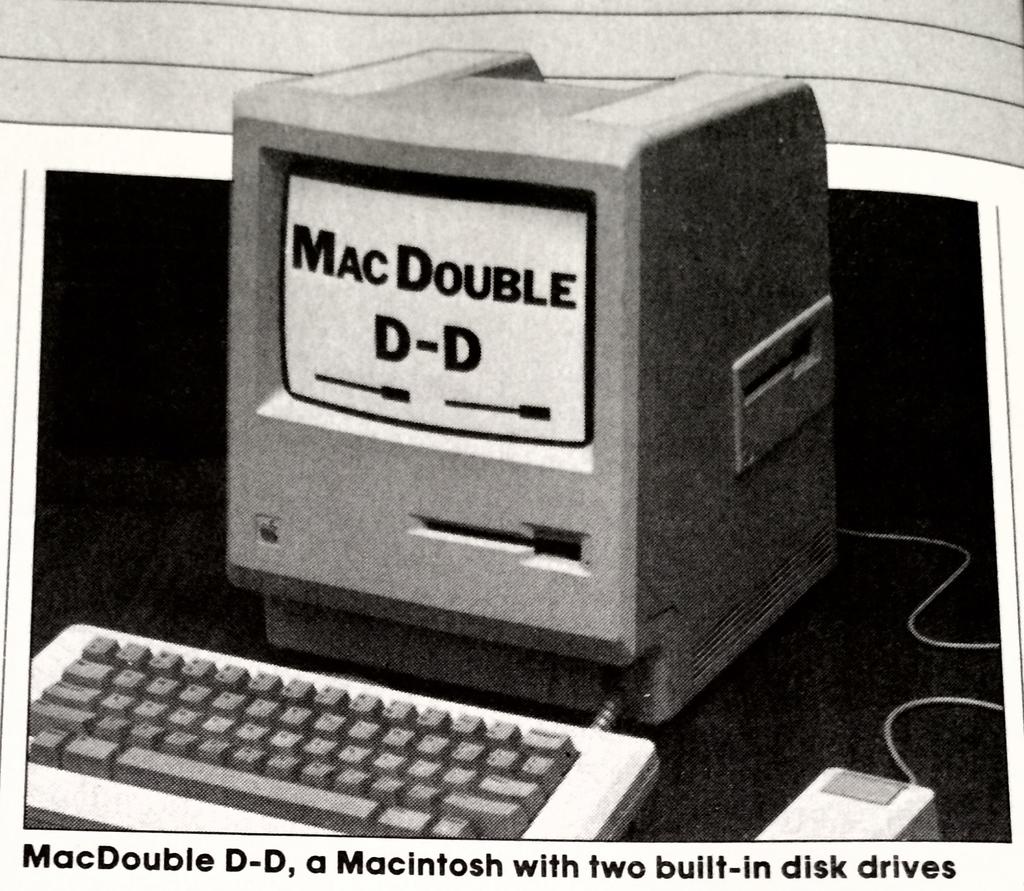What does this mac have built in?
Offer a terse response. Two disk drives. What brand is this computer?
Make the answer very short. Macintosh. 